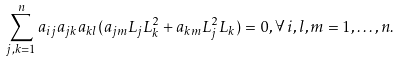Convert formula to latex. <formula><loc_0><loc_0><loc_500><loc_500>\sum _ { j , k = 1 } ^ { n } a _ { i j } a _ { j k } a _ { k l } ( a _ { j m } L _ { j } L _ { k } ^ { 2 } + a _ { k m } L _ { j } ^ { 2 } L _ { k } ) = 0 , \forall \, i , l , m = 1 , \dots , n .</formula> 